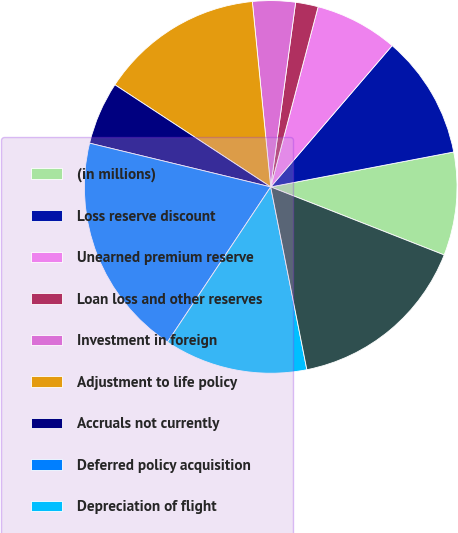Convert chart to OTSL. <chart><loc_0><loc_0><loc_500><loc_500><pie_chart><fcel>(in millions)<fcel>Loss reserve discount<fcel>Unearned premium reserve<fcel>Loan loss and other reserves<fcel>Investment in foreign<fcel>Adjustment to life policy<fcel>Accruals not currently<fcel>Deferred policy acquisition<fcel>Depreciation of flight<fcel>Unrealized appreciation of<nl><fcel>8.95%<fcel>10.7%<fcel>7.2%<fcel>1.96%<fcel>3.71%<fcel>14.19%<fcel>5.46%<fcel>19.43%<fcel>12.45%<fcel>15.94%<nl></chart> 